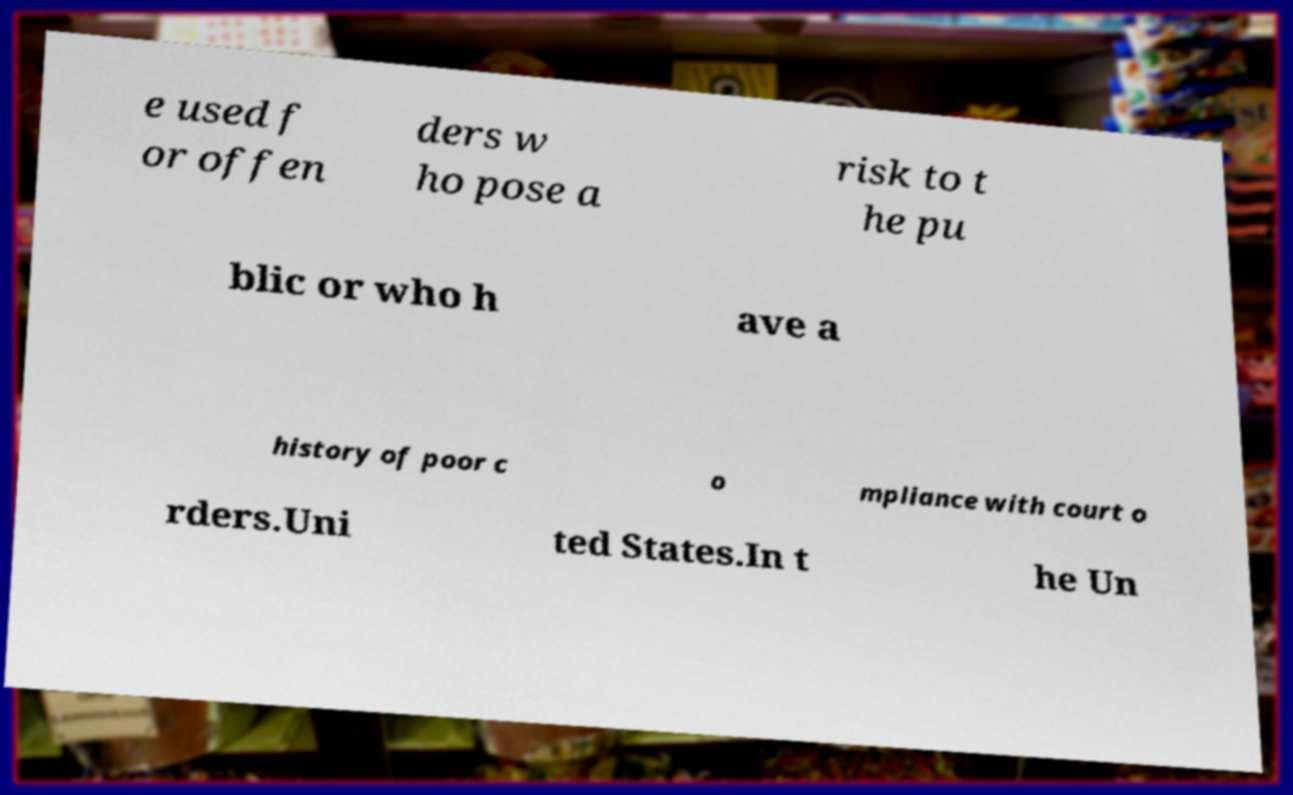Could you assist in decoding the text presented in this image and type it out clearly? e used f or offen ders w ho pose a risk to t he pu blic or who h ave a history of poor c o mpliance with court o rders.Uni ted States.In t he Un 